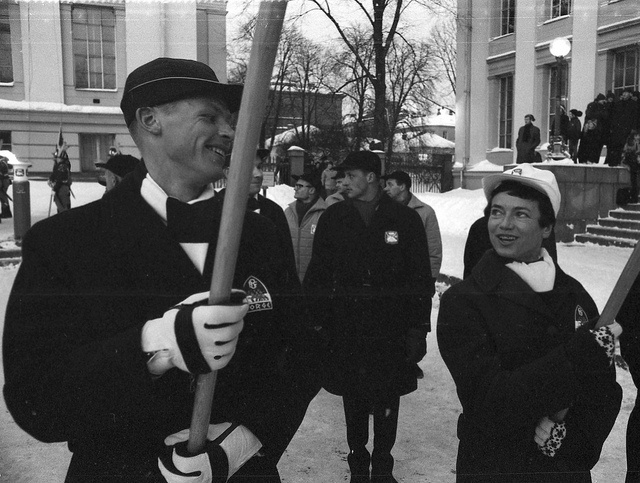Describe the objects in this image and their specific colors. I can see people in gray, black, darkgray, and lightgray tones, people in gray, black, darkgray, and lightgray tones, people in gray, black, and lightgray tones, baseball glove in gray, black, darkgray, and lightgray tones, and people in gray, black, darkgray, and lightgray tones in this image. 